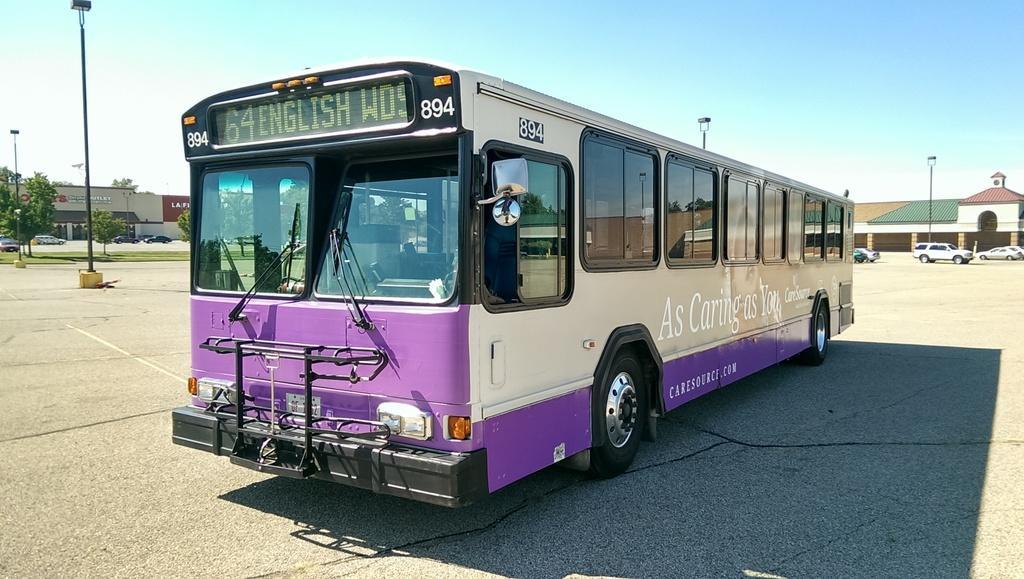Describe this image in one or two sentences. In this image there is a bus on the road, behind there is a building, cars on road and some light poles. 